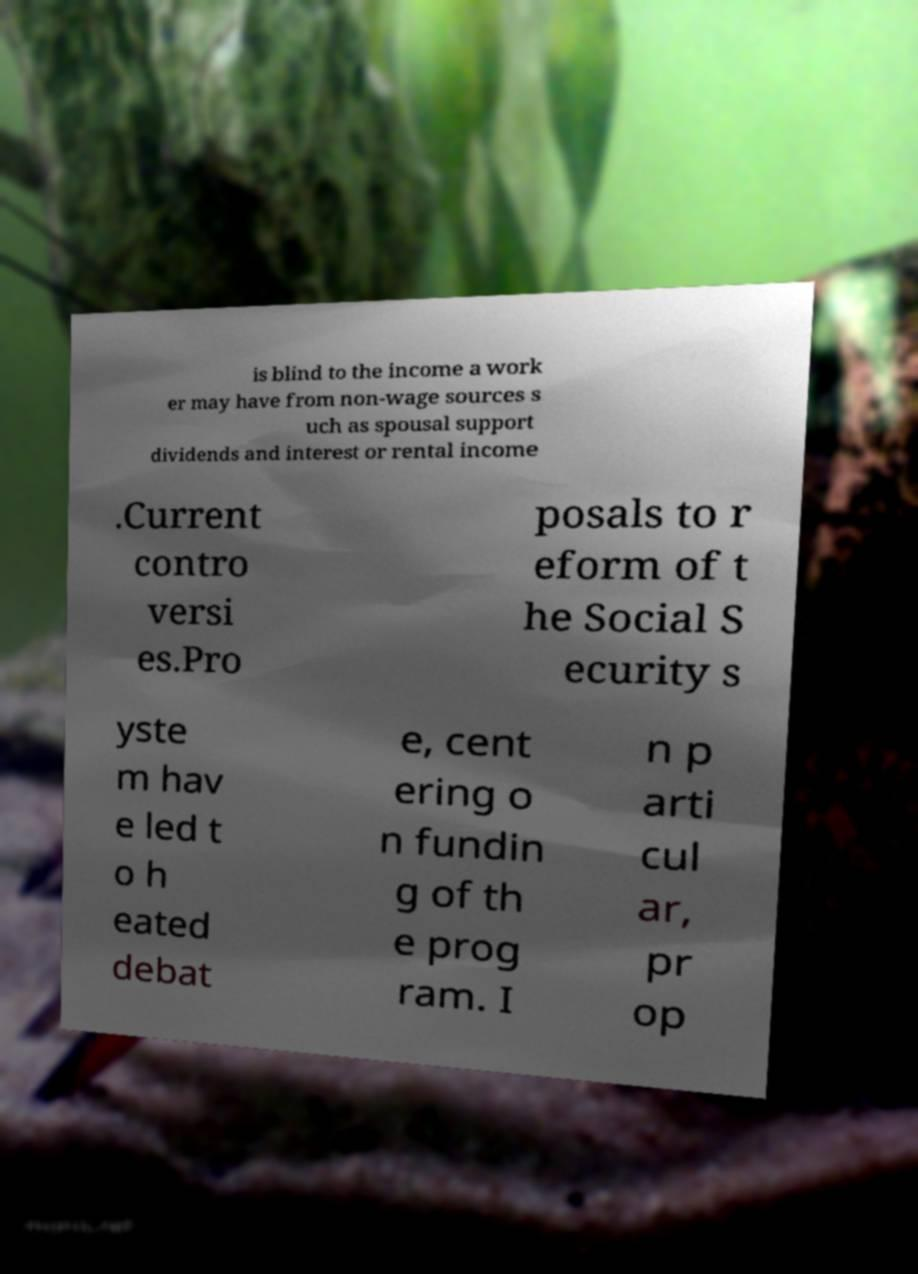For documentation purposes, I need the text within this image transcribed. Could you provide that? is blind to the income a work er may have from non-wage sources s uch as spousal support dividends and interest or rental income .Current contro versi es.Pro posals to r eform of t he Social S ecurity s yste m hav e led t o h eated debat e, cent ering o n fundin g of th e prog ram. I n p arti cul ar, pr op 